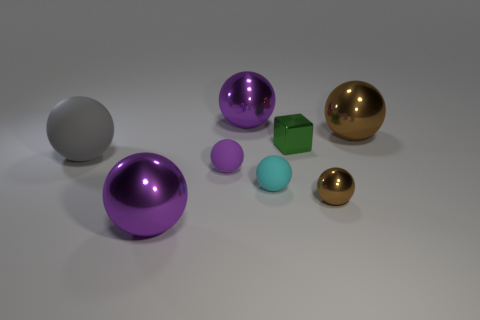How many purple balls must be subtracted to get 1 purple balls? 2 Subtract all brown blocks. How many purple spheres are left? 3 Subtract all cyan spheres. How many spheres are left? 6 Subtract 2 spheres. How many spheres are left? 5 Subtract all purple rubber spheres. How many spheres are left? 6 Subtract all brown spheres. Subtract all gray cubes. How many spheres are left? 5 Add 1 blue matte objects. How many objects exist? 9 Subtract all balls. How many objects are left? 1 Subtract 1 brown balls. How many objects are left? 7 Subtract all small cubes. Subtract all large purple blocks. How many objects are left? 7 